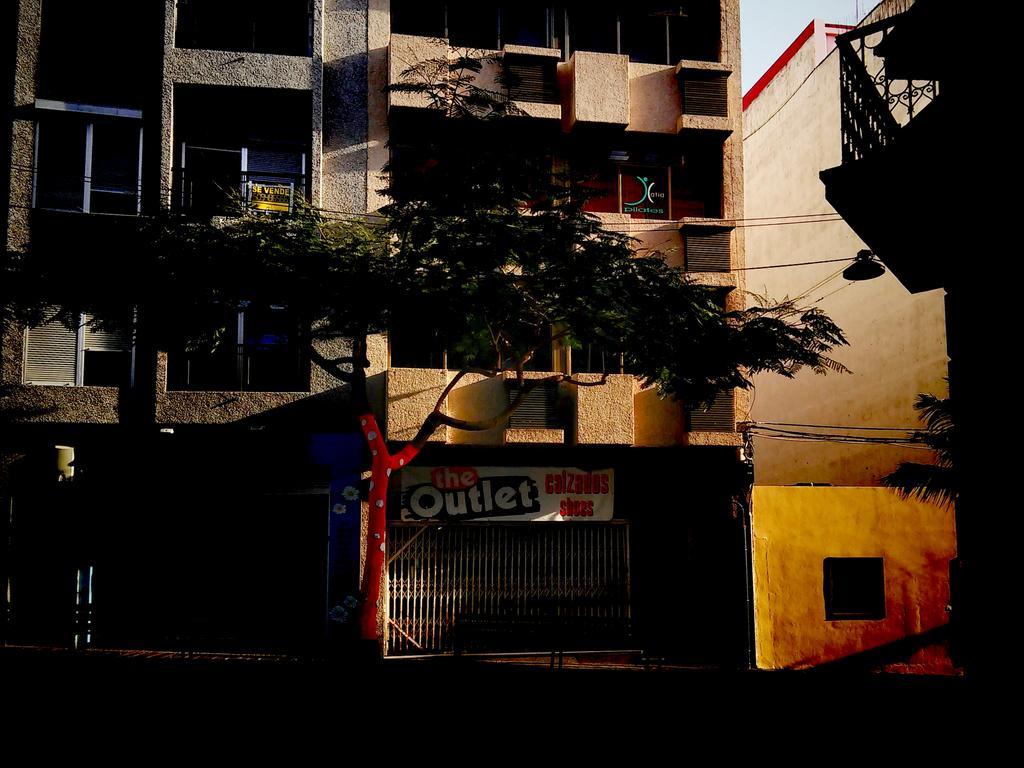Describe this image in one or two sentences. In the center of the image there is a building. There is a gate. There is a tree. There are windows. 